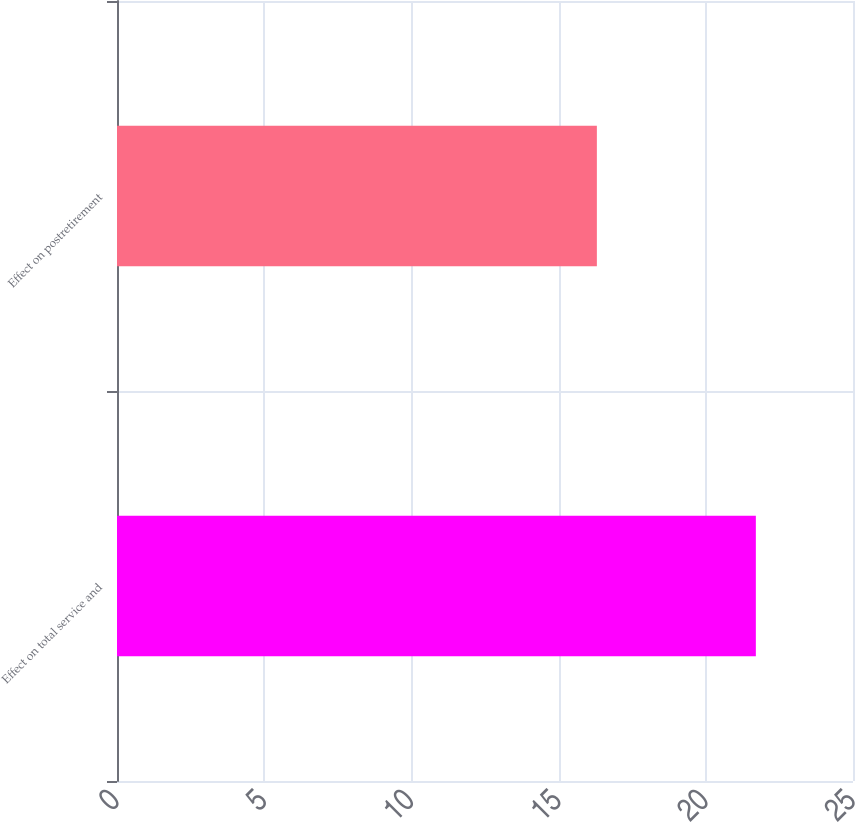Convert chart. <chart><loc_0><loc_0><loc_500><loc_500><bar_chart><fcel>Effect on total service and<fcel>Effect on postretirement<nl><fcel>21.7<fcel>16.3<nl></chart> 